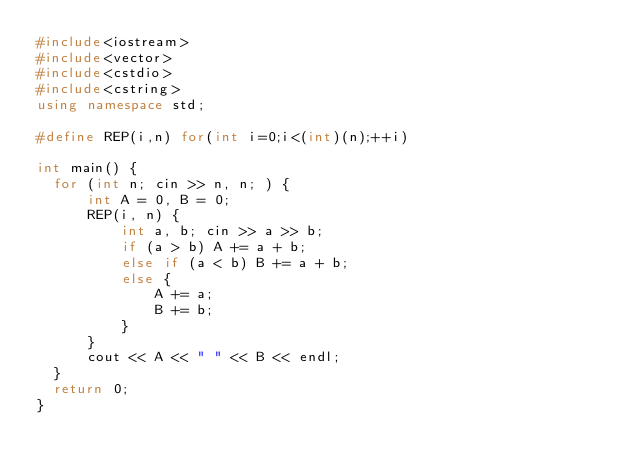<code> <loc_0><loc_0><loc_500><loc_500><_C++_>#include<iostream>
#include<vector>
#include<cstdio>
#include<cstring>
using namespace std;

#define REP(i,n) for(int i=0;i<(int)(n);++i)

int main() {
  for (int n; cin >> n, n; ) {
      int A = 0, B = 0;
      REP(i, n) {
          int a, b; cin >> a >> b;
          if (a > b) A += a + b;
          else if (a < b) B += a + b;
          else {
              A += a;
              B += b;
          }
      }
      cout << A << " " << B << endl;
  }
  return 0;
}</code> 